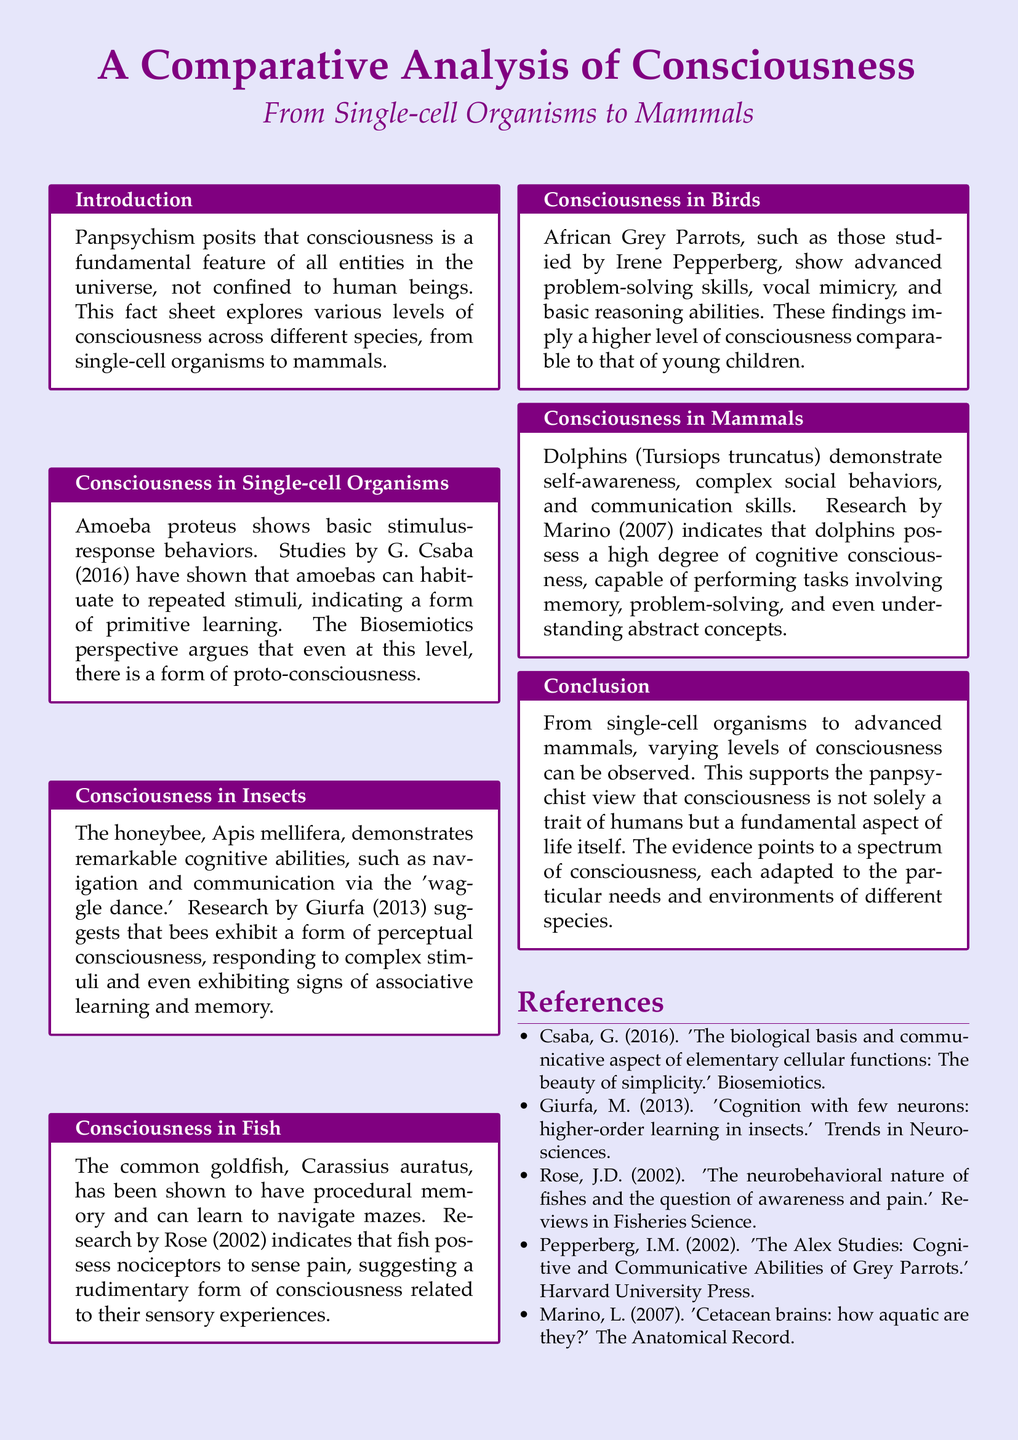What is the primary focus of the fact sheet? The fact sheet explores various levels of consciousness across different species, from single-cell organisms to mammals.
Answer: levels of consciousness Who conducted research on the consciousness of amoeba? G. Csaba is mentioned as the researcher who studied amoebas and their behaviors.
Answer: G. Csaba What cognitive ability do honeybees demonstrate according to the document? Honeybees are noted for their navigation and communication via the 'waggle dance.'
Answer: navigation and communication Which animal is referenced for showing self-awareness? The fact sheet mentions dolphins as the species demonstrating self-awareness.
Answer: dolphins What is the conclusion about consciousness across different species? The conclusion states that varying levels of consciousness support the panpsychist view that consciousness is a fundamental aspect of life.
Answer: fundamental aspect of life What type of consciousness is attributed to African Grey Parrots? The document suggests that African Grey Parrots exhibit a higher level of consciousness comparable to that of young children.
Answer: higher level of consciousness How many references are listed in the document? The references section lists five distinct sources related to the studies mentioned.
Answer: five What year was the research by Rose conducted? The document states that Rose conducted research in 2002 relevant to the consciousness of fish.
Answer: 2002 Which species is specifically mentioned as having procedural memory? The common goldfish is highlighted for showing procedural memory in the document.
Answer: common goldfish What perspective argues for the presence of proto-consciousness in single-cell organisms? The Biosemiotics perspective is cited as arguing for a form of proto-consciousness in single-cell organisms.
Answer: Biosemiotics perspective 